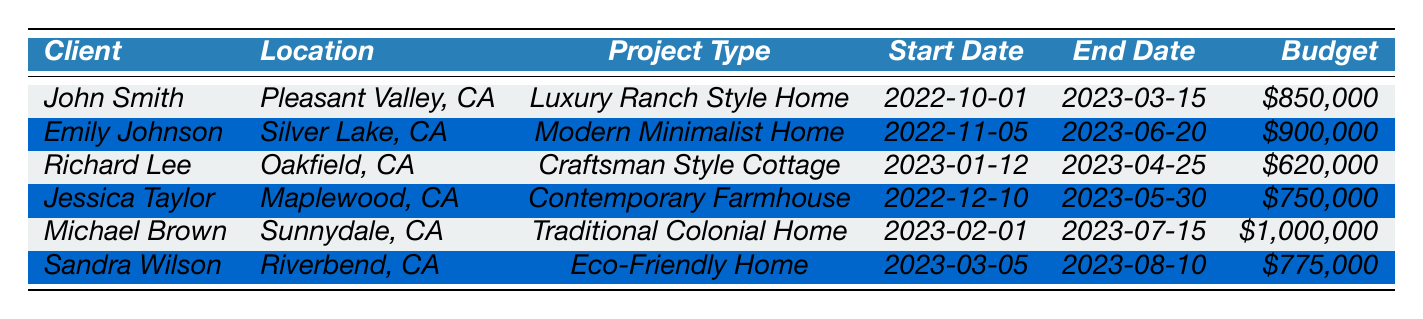What is the project type for John Smith's home? The table lists John Smith's project type in the corresponding row under the "Project Type" column. It is noted as a "Luxury Ranch Style Home".
Answer: Luxury Ranch Style Home How many days did it take to complete Richard Lee's project? Richard Lee's project has the total duration listed as 103 days in the "Total Duration" column.
Answer: 103 days Which project had the highest budget? By comparing the budgets listed for each project, Michael Brown’s project at $1,000,000 is the highest among all.
Answer: $1,000,000 What is the average duration of all projects listed? To find the average, first sum the total duration of all projects: 144 + 228 + 103 + 171 + 165 + 128 = 1039. Then, divide by the number of projects, which is 6. The average duration is 1039 / 6 = approximately 173.17 days.
Answer: approximately 173.17 days Did any project complete in under 100 days? Looking at the durations in the "Total Duration" column, all projects have durations above 100 days; hence none completed in under 100 days.
Answer: No How does the budget for Emily Johnson's project compare to that of Richard Lee's? Emily Johnson's project budget is $900,000 while Richard Lee's is $620,000. The difference is $900,000 - $620,000 = $280,000, so Emily's budget is higher by $280,000.
Answer: $280,000 How many projects were completed in the month of March 2023? Observing the completion dates, John Smith and Sandra Wilson completed their projects in March 2023. Thus, there are 2 projects completed that month.
Answer: 2 What is the total budget for all the projects combined? First, note the budgets: $850,000 + $900,000 + $620,000 + $750,000 + $1,000,000 + $775,000 equals a total budget of $4,895,000.
Answer: $4,895,000 Which client’s project took the longest to complete, and how long was it? By reviewing the "Total Duration" column, the longest project is Emily Johnson's at 228 days.
Answer: Emily Johnson, 228 days Is the completion date for Michael Brown's project later than that of Jessica Taylor's? Michael Brown's project completion date is July 15, 2023, while Jessica Taylor's is May 30, 2023; since July is later than May, Michael's completion is indeed later.
Answer: Yes 